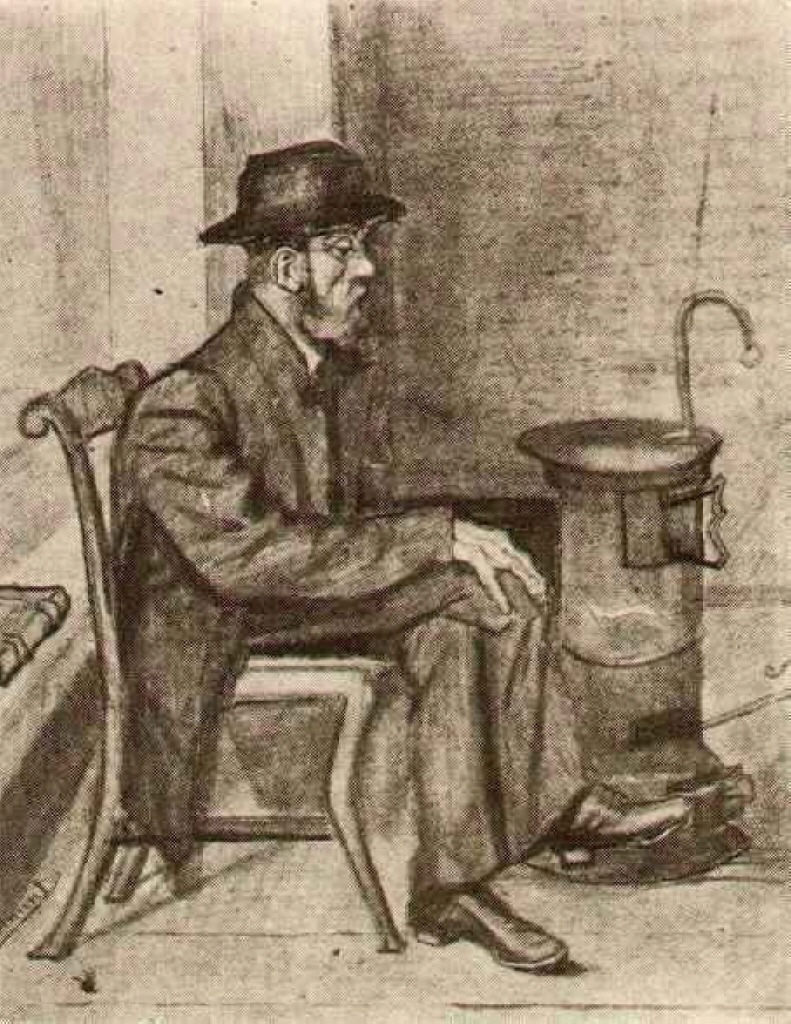Imagine the life stories of other people he might know or interact with regularly. One can imagine he might know a blacksmith who spends his days forging tools, a kind-hearted shopkeeper always ready with a warm loaf of bread, and a school teacher with a love for books but whose heart aches with unfulfilled dreams. Each of these people would have their own unique struggles and triumphs, intertwining with his story in the fabric of daily life. For instance, the blacksmith might be battling the loss of the old ways to industrial advances, while the schoolteacher might be facing the challenges of educating the new wave of young minds in a rapidly changing world. 